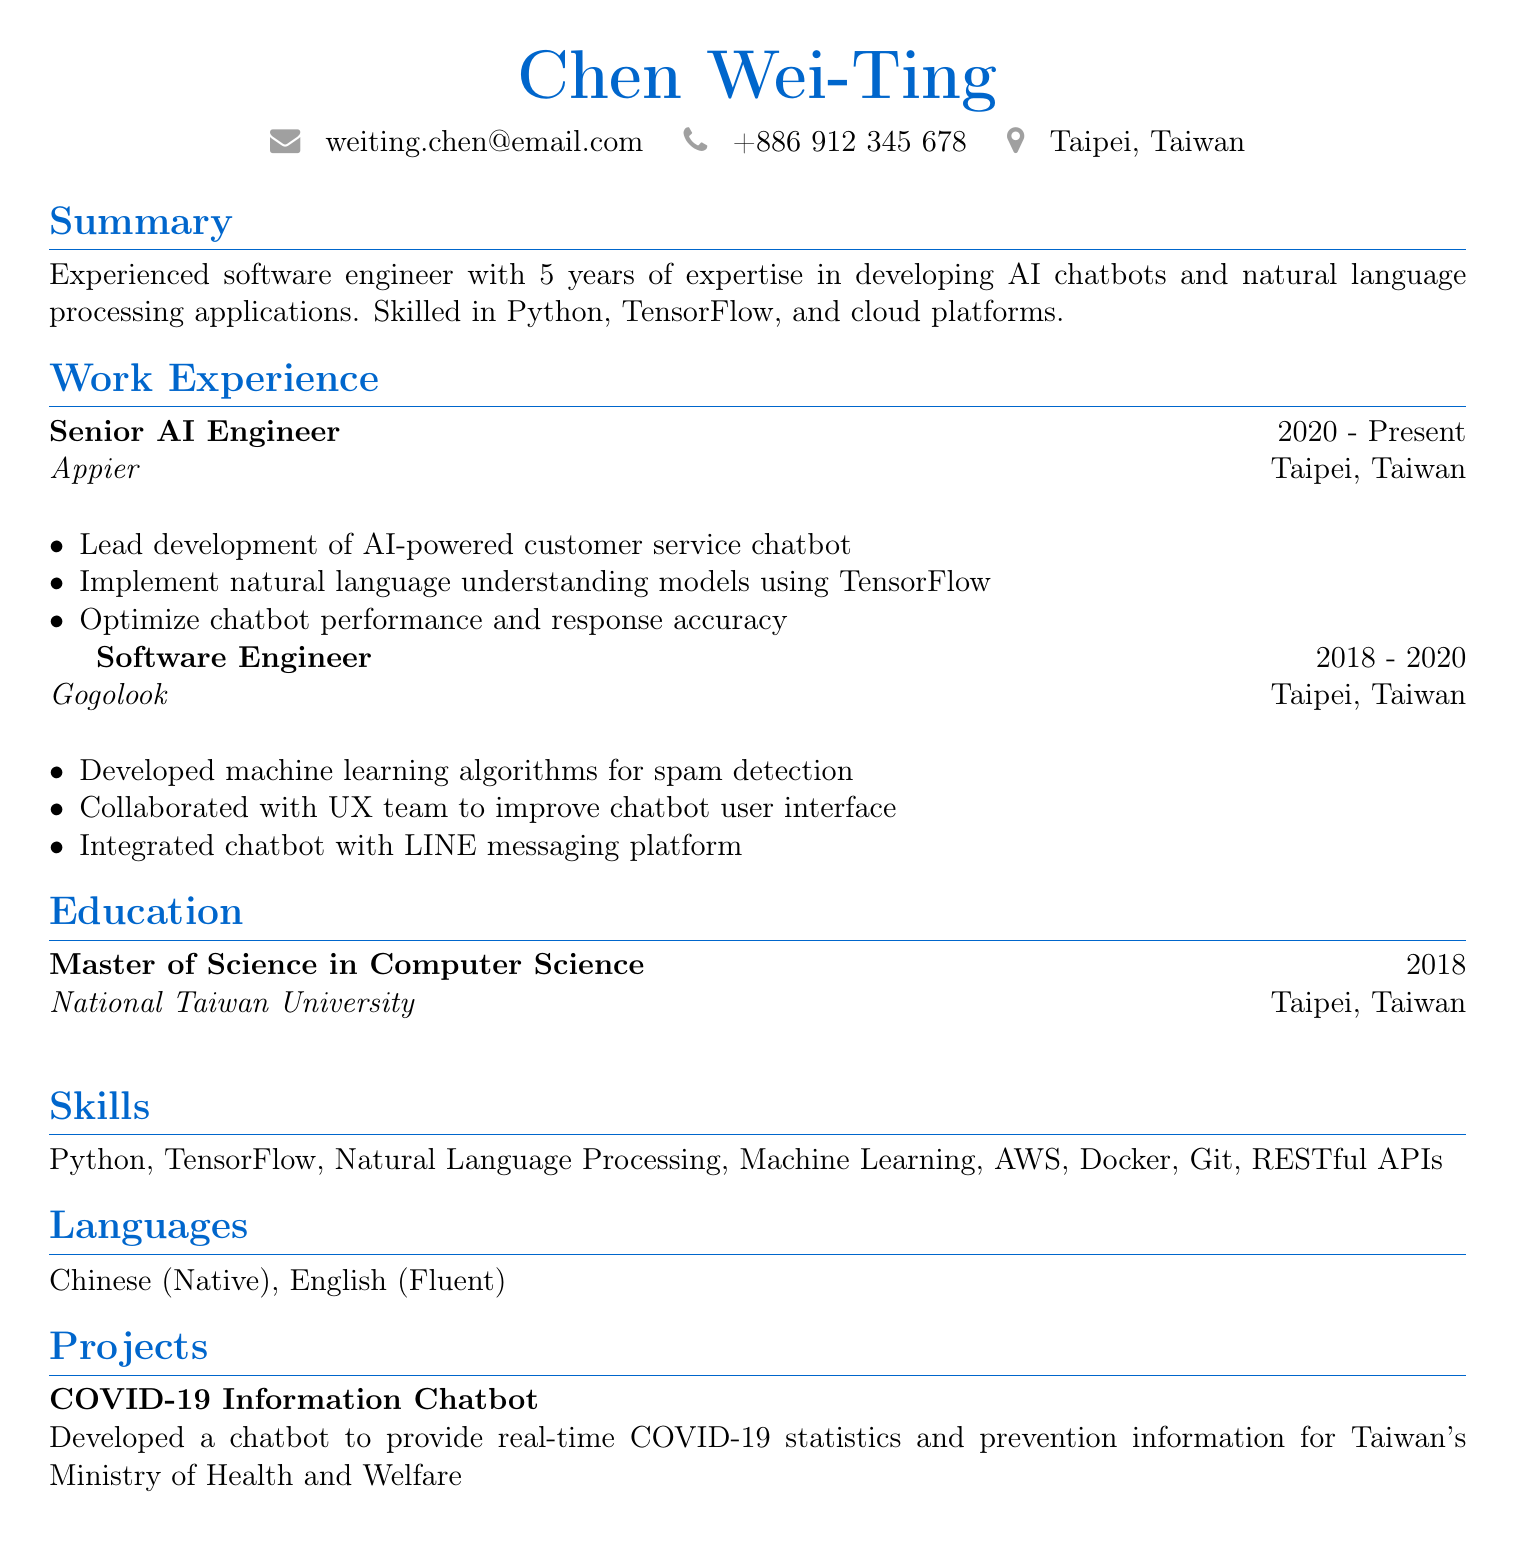What is the name of the software engineer? The document lists the name as Chen Wei-Ting.
Answer: Chen Wei-Ting What is the primary programming language the engineer is skilled in? Python is mentioned as one of the skills in the document.
Answer: Python Which company does the engineer currently work for? The current job position is listed at Appier.
Answer: Appier What degree did the engineer obtain? The document states that the engineer has a Master of Science in Computer Science.
Answer: Master of Science in Computer Science How many years of experience does the engineer have? The summary states that the engineer has 5 years of experience.
Answer: 5 years What project did the engineer work on related to COVID-19? The project is described as the COVID-19 Information Chatbot.
Answer: COVID-19 Information Chatbot Which cloud platform is mentioned in the skills? AWS is one of the skills explicitly listed.
Answer: AWS What was the role of the engineer at Gogolook? The document describes the role as Software Engineer.
Answer: Software Engineer In which city is the engineer located? The document specifies Taipei, Taiwan as the location.
Answer: Taipei, Taiwan 